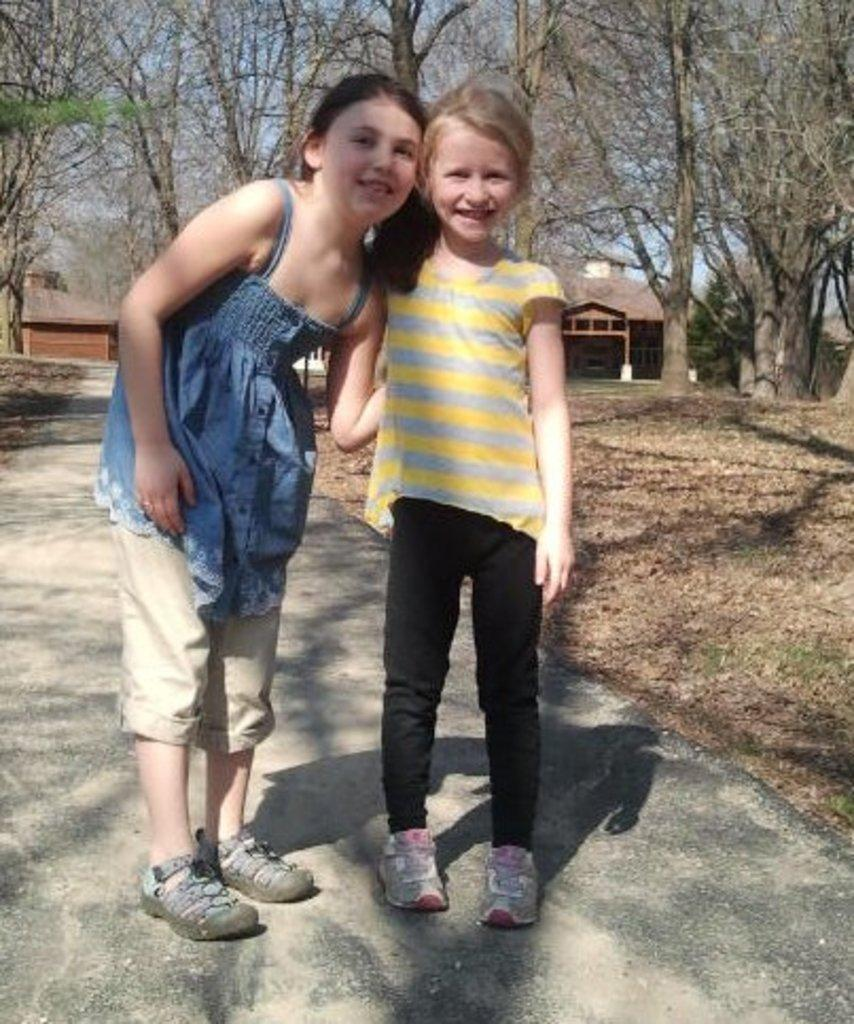How many kids are in the image? There are two kids in the image. What can be seen in the background of the image? There are buildings and trees in the background of the image. What type of hair is visible on the edge of the feast in the image? There is no feast or hair present in the image. 